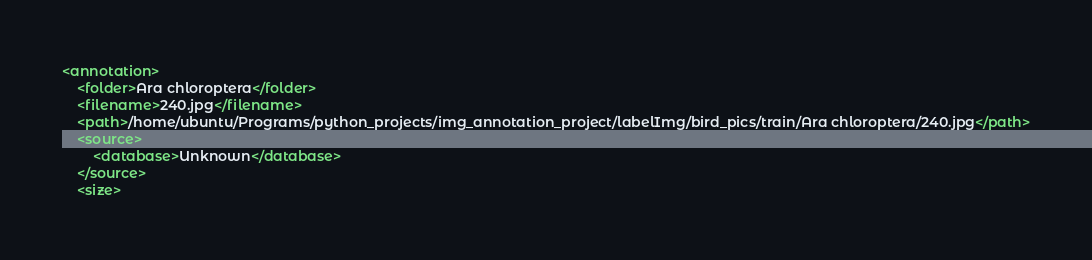Convert code to text. <code><loc_0><loc_0><loc_500><loc_500><_XML_><annotation>
	<folder>Ara chloroptera</folder>
	<filename>240.jpg</filename>
	<path>/home/ubuntu/Programs/python_projects/img_annotation_project/labelImg/bird_pics/train/Ara chloroptera/240.jpg</path>
	<source>
		<database>Unknown</database>
	</source>
	<size></code> 